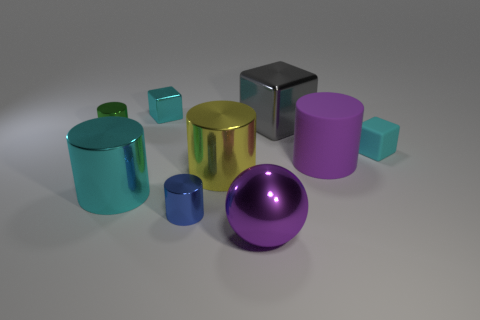Subtract all green cylinders. How many cylinders are left? 4 Subtract 1 cylinders. How many cylinders are left? 4 Subtract all green cylinders. How many cylinders are left? 4 Subtract all red cylinders. Subtract all red blocks. How many cylinders are left? 5 Add 1 tiny blue metallic objects. How many objects exist? 10 Subtract all spheres. How many objects are left? 8 Subtract all tiny blue metallic things. Subtract all tiny purple rubber things. How many objects are left? 8 Add 3 small things. How many small things are left? 7 Add 6 large brown matte cylinders. How many large brown matte cylinders exist? 6 Subtract 0 brown cylinders. How many objects are left? 9 